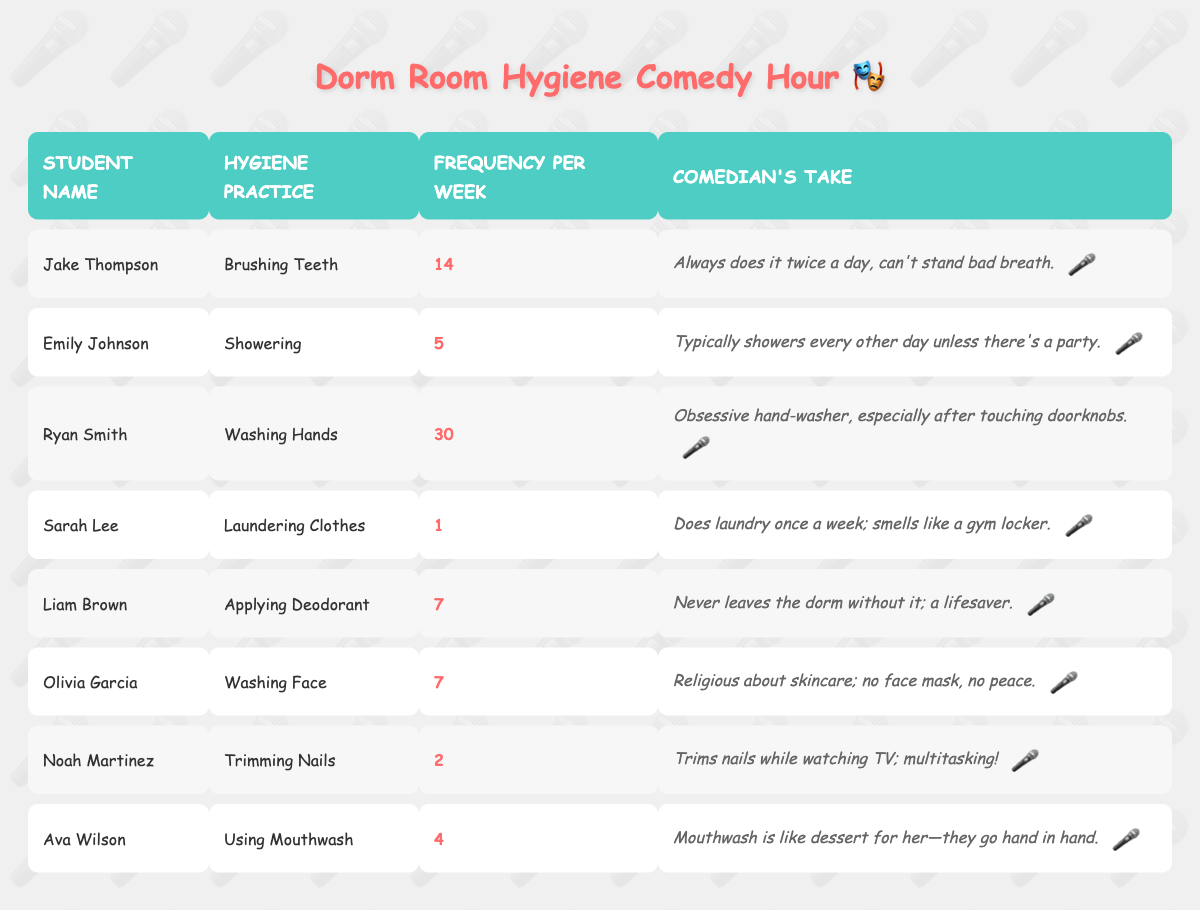What is the frequency of washing hands per week? The table lists Ryan Smith as the student associated with washing hands, and his frequency per week is indicated as 30.
Answer: 30 Which hygiene practice is done most frequently by any student? Ryan Smith practices washing hands 30 times a week, which is higher than any other listed frequency in the table.
Answer: Washing hands Is there a student who does laundry more than once a week? Sarah Lee only launders clothes once a week, and no other student is listed with a higher frequency for this practice.
Answer: No What is the average frequency of applying deodorant and washing face? The frequencies for applying deodorant and washing face are both 7. Hence, the average is calculated as (7 + 7) / 2 = 7.
Answer: 7 Which student has the lowest frequency of hygiene practices listed? Sarah Lee launders clothes just once a week, which is the lowest frequency compared to other hygiene practices in the table.
Answer: Sarah Lee How many students practice washing face? According to the table, one student, Olivia Garcia, practices washing her face, as indicated by the entry for her hygiene practice.
Answer: 1 If you sum up the frequencies for all the hygiene practices, what is the total? The total is calculated by adding up all the frequencies: 14 + 5 + 30 + 1 + 7 + 7 + 2 + 4 = 70.
Answer: 70 Is applying deodorant a common habit among students according to this table? Liam Brown applies deodorant 7 times a week, indicating that it is a common habit among the students listed.
Answer: Yes How many hygiene practices are performed at least 5 times a week? Three students (Jake, Ryan, and Emily) have frequencies at or above 5 times a week: 14, 30, and 5 respectively.
Answer: 3 